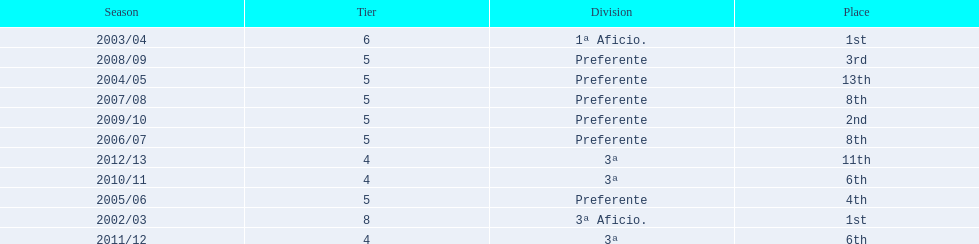What was the number of wins for preferente? 6. 